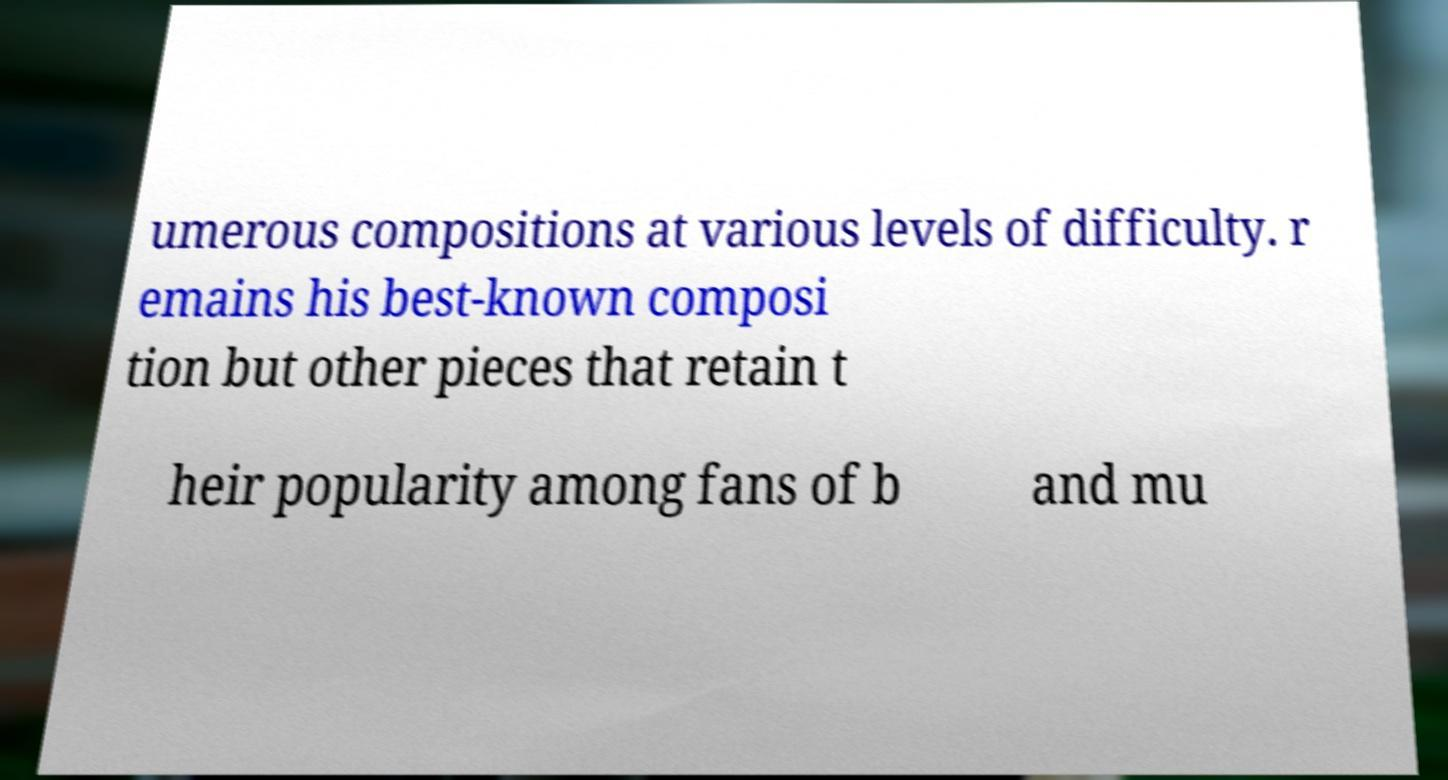Can you accurately transcribe the text from the provided image for me? umerous compositions at various levels of difficulty. r emains his best-known composi tion but other pieces that retain t heir popularity among fans of b and mu 